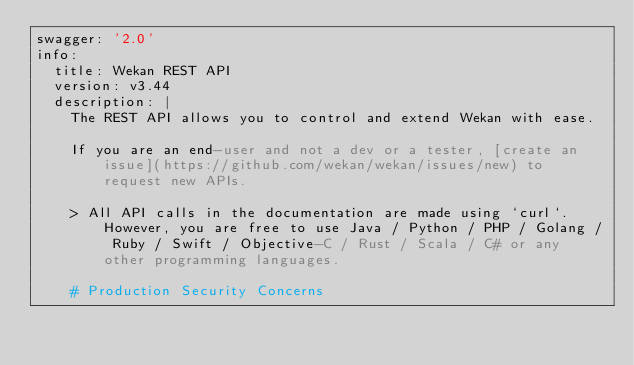<code> <loc_0><loc_0><loc_500><loc_500><_YAML_>swagger: '2.0'
info:
  title: Wekan REST API
  version: v3.44
  description: |
    The REST API allows you to control and extend Wekan with ease.

    If you are an end-user and not a dev or a tester, [create an issue](https://github.com/wekan/wekan/issues/new) to request new APIs.

    > All API calls in the documentation are made using `curl`.  However, you are free to use Java / Python / PHP / Golang / Ruby / Swift / Objective-C / Rust / Scala / C# or any other programming languages.

    # Production Security Concerns</code> 